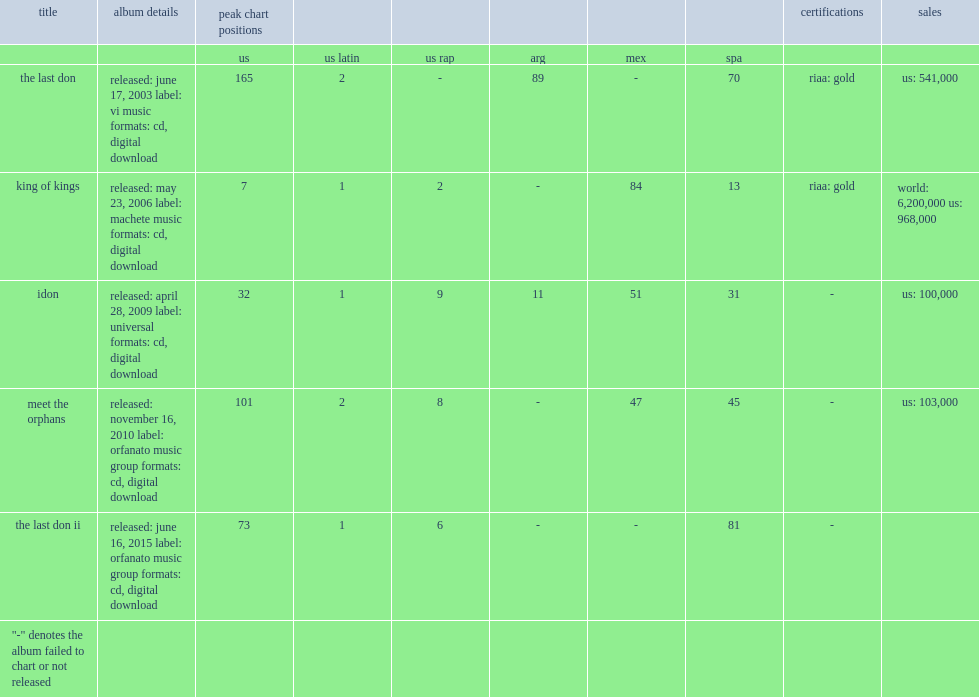In the u.s., how many peak chart positions did the don omar discography reach? 165.0. 